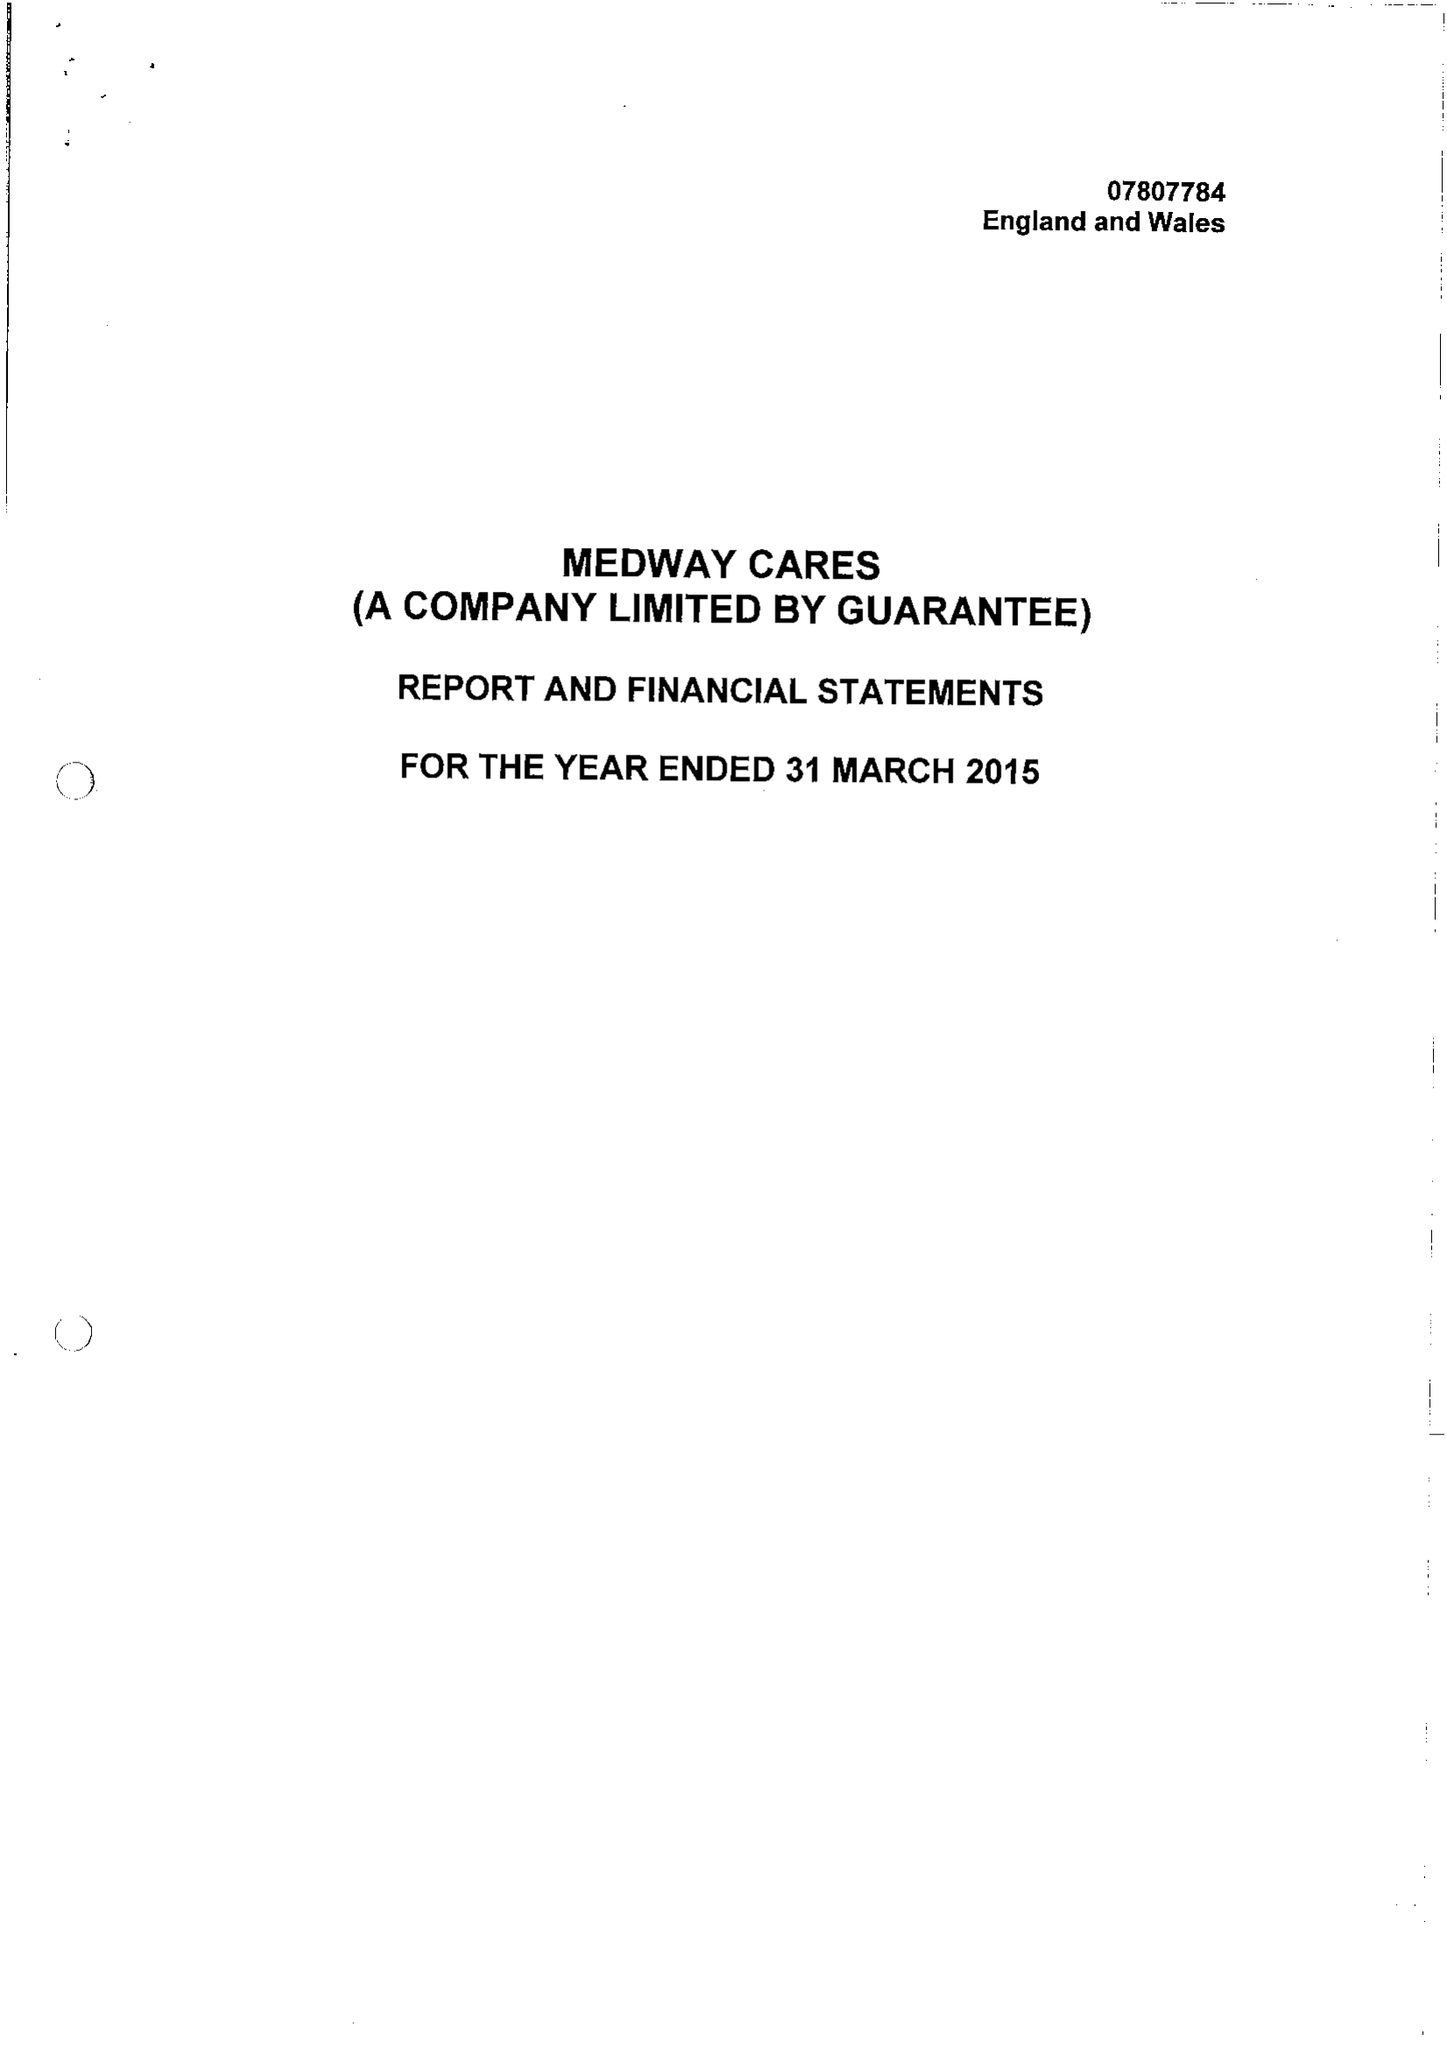What is the value for the address__street_line?
Answer the question using a single word or phrase. BAILEY DRIVE 